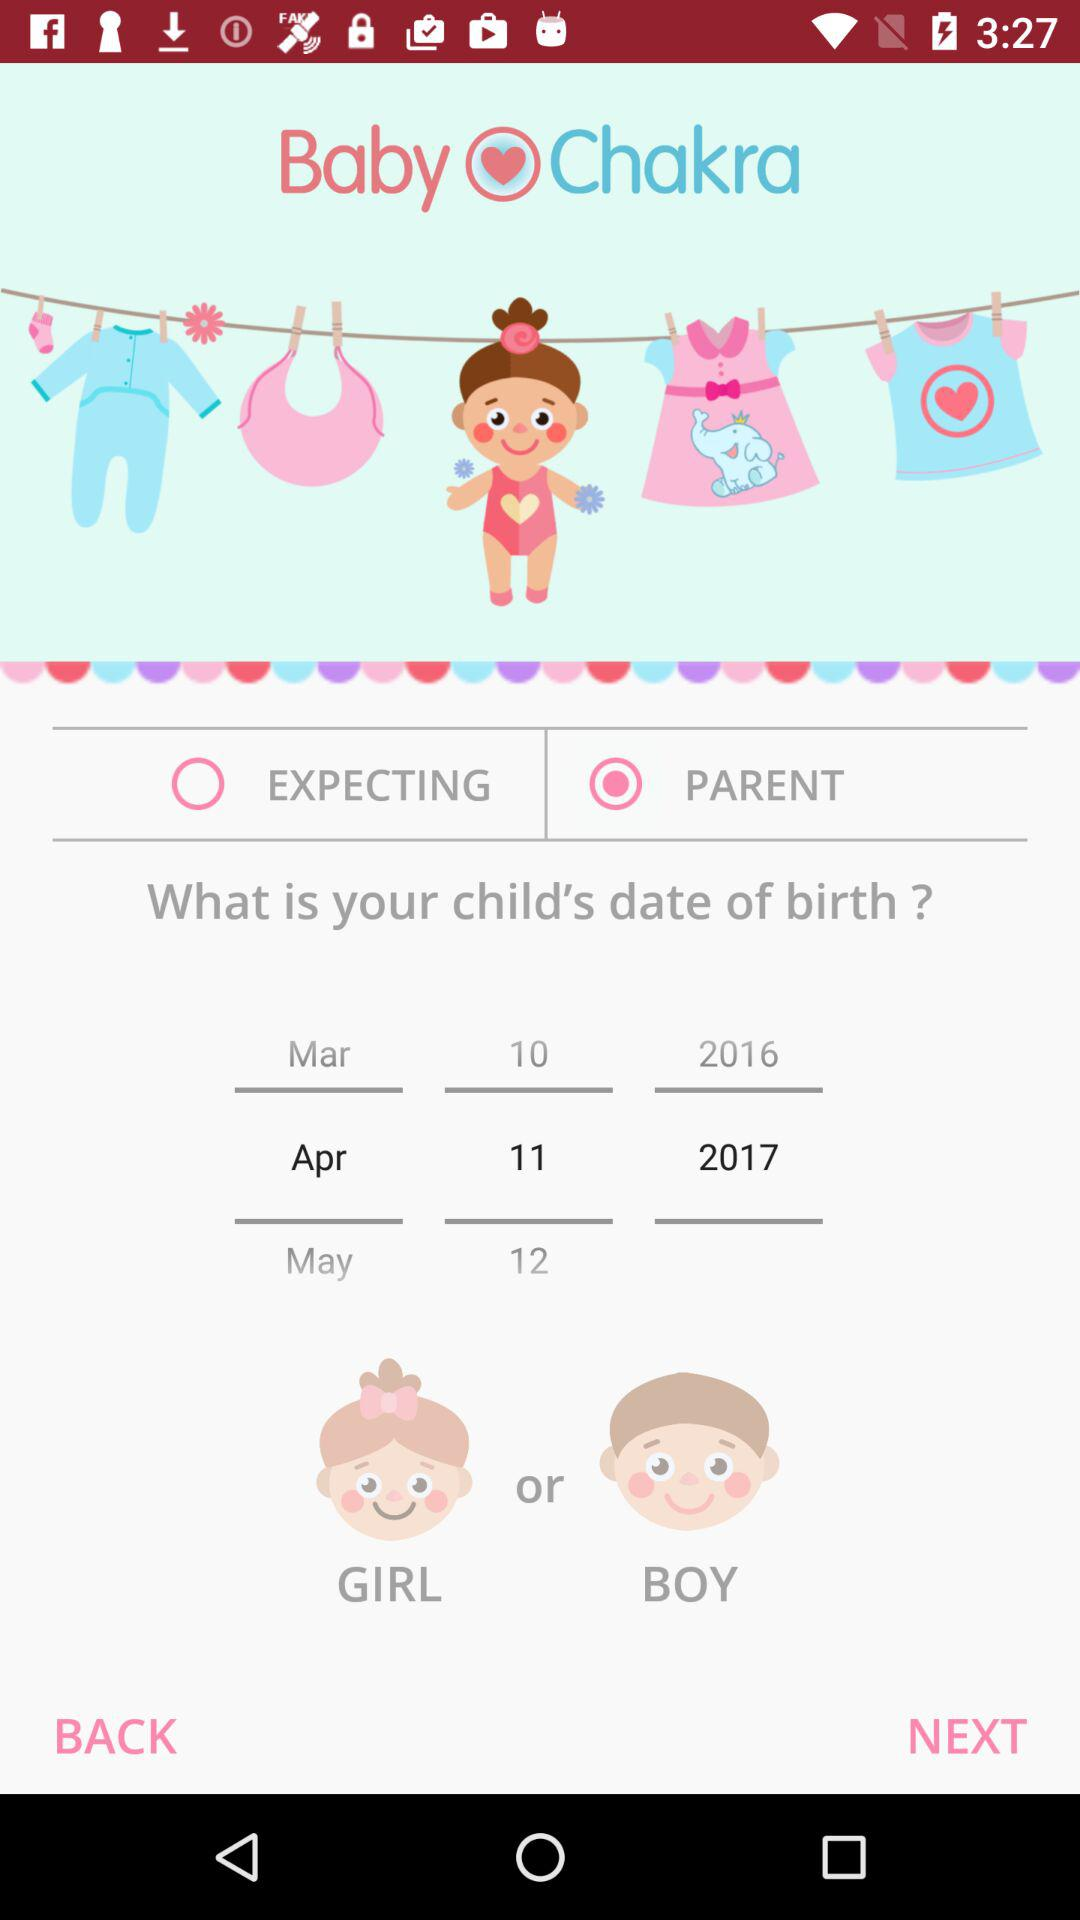What is the app name? The app name is "Baby Chakra". 